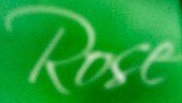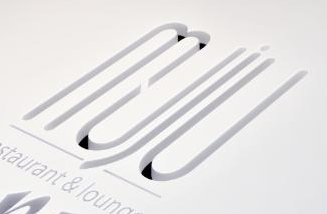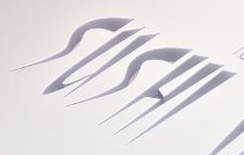What text is displayed in these images sequentially, separated by a semicolon? Rose; muju; SUSHI 